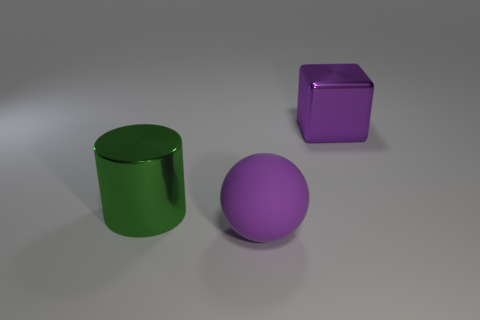Subtract all cubes. How many objects are left? 2 Add 1 small purple matte cubes. How many objects exist? 4 Subtract 0 green blocks. How many objects are left? 3 Subtract 1 cylinders. How many cylinders are left? 0 Subtract all red spheres. Subtract all blue cylinders. How many spheres are left? 1 Subtract all blue cylinders. How many green blocks are left? 0 Subtract all blue things. Subtract all large metal cylinders. How many objects are left? 2 Add 3 big things. How many big things are left? 6 Add 1 large purple matte balls. How many large purple matte balls exist? 2 